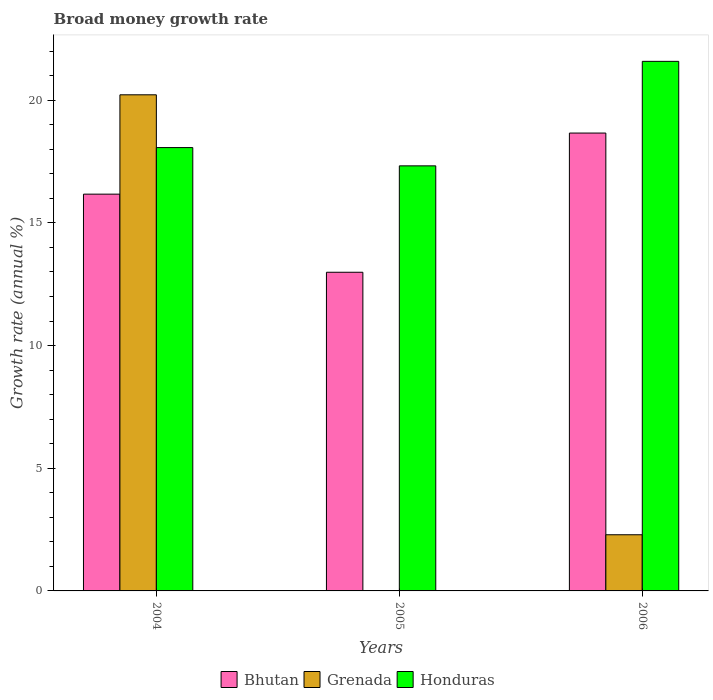How many different coloured bars are there?
Ensure brevity in your answer.  3. Are the number of bars per tick equal to the number of legend labels?
Ensure brevity in your answer.  No. How many bars are there on the 1st tick from the left?
Your answer should be compact. 3. How many bars are there on the 2nd tick from the right?
Make the answer very short. 2. What is the label of the 2nd group of bars from the left?
Offer a terse response. 2005. In how many cases, is the number of bars for a given year not equal to the number of legend labels?
Your answer should be compact. 1. What is the growth rate in Bhutan in 2005?
Provide a succinct answer. 12.99. Across all years, what is the maximum growth rate in Grenada?
Offer a terse response. 20.22. Across all years, what is the minimum growth rate in Bhutan?
Ensure brevity in your answer.  12.99. In which year was the growth rate in Grenada maximum?
Your response must be concise. 2004. What is the total growth rate in Bhutan in the graph?
Provide a short and direct response. 47.83. What is the difference between the growth rate in Bhutan in 2004 and that in 2006?
Provide a succinct answer. -2.49. What is the difference between the growth rate in Bhutan in 2005 and the growth rate in Honduras in 2006?
Provide a short and direct response. -8.6. What is the average growth rate in Honduras per year?
Keep it short and to the point. 18.99. In the year 2006, what is the difference between the growth rate in Grenada and growth rate in Bhutan?
Keep it short and to the point. -16.37. In how many years, is the growth rate in Honduras greater than 1 %?
Offer a terse response. 3. What is the ratio of the growth rate in Bhutan in 2005 to that in 2006?
Keep it short and to the point. 0.7. Is the growth rate in Bhutan in 2005 less than that in 2006?
Offer a very short reply. Yes. What is the difference between the highest and the second highest growth rate in Honduras?
Your answer should be very brief. 3.51. What is the difference between the highest and the lowest growth rate in Grenada?
Offer a very short reply. 20.22. In how many years, is the growth rate in Honduras greater than the average growth rate in Honduras taken over all years?
Keep it short and to the point. 1. How many bars are there?
Your answer should be very brief. 8. What is the difference between two consecutive major ticks on the Y-axis?
Offer a terse response. 5. Does the graph contain any zero values?
Ensure brevity in your answer.  Yes. How many legend labels are there?
Offer a terse response. 3. How are the legend labels stacked?
Your answer should be very brief. Horizontal. What is the title of the graph?
Ensure brevity in your answer.  Broad money growth rate. What is the label or title of the Y-axis?
Your answer should be very brief. Growth rate (annual %). What is the Growth rate (annual %) in Bhutan in 2004?
Provide a short and direct response. 16.17. What is the Growth rate (annual %) in Grenada in 2004?
Offer a terse response. 20.22. What is the Growth rate (annual %) in Honduras in 2004?
Make the answer very short. 18.07. What is the Growth rate (annual %) in Bhutan in 2005?
Provide a short and direct response. 12.99. What is the Growth rate (annual %) of Honduras in 2005?
Your answer should be compact. 17.33. What is the Growth rate (annual %) of Bhutan in 2006?
Ensure brevity in your answer.  18.66. What is the Growth rate (annual %) of Grenada in 2006?
Offer a terse response. 2.29. What is the Growth rate (annual %) of Honduras in 2006?
Your answer should be compact. 21.59. Across all years, what is the maximum Growth rate (annual %) in Bhutan?
Provide a succinct answer. 18.66. Across all years, what is the maximum Growth rate (annual %) in Grenada?
Your answer should be compact. 20.22. Across all years, what is the maximum Growth rate (annual %) of Honduras?
Offer a terse response. 21.59. Across all years, what is the minimum Growth rate (annual %) of Bhutan?
Provide a short and direct response. 12.99. Across all years, what is the minimum Growth rate (annual %) in Grenada?
Offer a terse response. 0. Across all years, what is the minimum Growth rate (annual %) in Honduras?
Make the answer very short. 17.33. What is the total Growth rate (annual %) in Bhutan in the graph?
Your answer should be compact. 47.83. What is the total Growth rate (annual %) of Grenada in the graph?
Provide a short and direct response. 22.51. What is the total Growth rate (annual %) in Honduras in the graph?
Offer a very short reply. 56.98. What is the difference between the Growth rate (annual %) of Bhutan in 2004 and that in 2005?
Your answer should be very brief. 3.18. What is the difference between the Growth rate (annual %) of Honduras in 2004 and that in 2005?
Your answer should be very brief. 0.74. What is the difference between the Growth rate (annual %) of Bhutan in 2004 and that in 2006?
Give a very brief answer. -2.49. What is the difference between the Growth rate (annual %) of Grenada in 2004 and that in 2006?
Provide a succinct answer. 17.93. What is the difference between the Growth rate (annual %) in Honduras in 2004 and that in 2006?
Give a very brief answer. -3.51. What is the difference between the Growth rate (annual %) of Bhutan in 2005 and that in 2006?
Provide a succinct answer. -5.67. What is the difference between the Growth rate (annual %) of Honduras in 2005 and that in 2006?
Your answer should be compact. -4.26. What is the difference between the Growth rate (annual %) of Bhutan in 2004 and the Growth rate (annual %) of Honduras in 2005?
Your answer should be very brief. -1.15. What is the difference between the Growth rate (annual %) in Grenada in 2004 and the Growth rate (annual %) in Honduras in 2005?
Your answer should be very brief. 2.9. What is the difference between the Growth rate (annual %) of Bhutan in 2004 and the Growth rate (annual %) of Grenada in 2006?
Your answer should be very brief. 13.88. What is the difference between the Growth rate (annual %) of Bhutan in 2004 and the Growth rate (annual %) of Honduras in 2006?
Provide a succinct answer. -5.41. What is the difference between the Growth rate (annual %) in Grenada in 2004 and the Growth rate (annual %) in Honduras in 2006?
Keep it short and to the point. -1.36. What is the difference between the Growth rate (annual %) of Bhutan in 2005 and the Growth rate (annual %) of Grenada in 2006?
Your response must be concise. 10.7. What is the difference between the Growth rate (annual %) of Bhutan in 2005 and the Growth rate (annual %) of Honduras in 2006?
Offer a terse response. -8.6. What is the average Growth rate (annual %) of Bhutan per year?
Provide a succinct answer. 15.94. What is the average Growth rate (annual %) in Grenada per year?
Offer a very short reply. 7.5. What is the average Growth rate (annual %) in Honduras per year?
Give a very brief answer. 18.99. In the year 2004, what is the difference between the Growth rate (annual %) of Bhutan and Growth rate (annual %) of Grenada?
Ensure brevity in your answer.  -4.05. In the year 2004, what is the difference between the Growth rate (annual %) in Bhutan and Growth rate (annual %) in Honduras?
Give a very brief answer. -1.9. In the year 2004, what is the difference between the Growth rate (annual %) of Grenada and Growth rate (annual %) of Honduras?
Ensure brevity in your answer.  2.15. In the year 2005, what is the difference between the Growth rate (annual %) in Bhutan and Growth rate (annual %) in Honduras?
Offer a very short reply. -4.34. In the year 2006, what is the difference between the Growth rate (annual %) of Bhutan and Growth rate (annual %) of Grenada?
Offer a very short reply. 16.37. In the year 2006, what is the difference between the Growth rate (annual %) in Bhutan and Growth rate (annual %) in Honduras?
Provide a short and direct response. -2.92. In the year 2006, what is the difference between the Growth rate (annual %) of Grenada and Growth rate (annual %) of Honduras?
Make the answer very short. -19.3. What is the ratio of the Growth rate (annual %) in Bhutan in 2004 to that in 2005?
Your answer should be compact. 1.25. What is the ratio of the Growth rate (annual %) in Honduras in 2004 to that in 2005?
Provide a succinct answer. 1.04. What is the ratio of the Growth rate (annual %) in Bhutan in 2004 to that in 2006?
Your answer should be very brief. 0.87. What is the ratio of the Growth rate (annual %) of Grenada in 2004 to that in 2006?
Keep it short and to the point. 8.83. What is the ratio of the Growth rate (annual %) of Honduras in 2004 to that in 2006?
Provide a short and direct response. 0.84. What is the ratio of the Growth rate (annual %) in Bhutan in 2005 to that in 2006?
Ensure brevity in your answer.  0.7. What is the ratio of the Growth rate (annual %) in Honduras in 2005 to that in 2006?
Provide a succinct answer. 0.8. What is the difference between the highest and the second highest Growth rate (annual %) of Bhutan?
Keep it short and to the point. 2.49. What is the difference between the highest and the second highest Growth rate (annual %) of Honduras?
Your answer should be compact. 3.51. What is the difference between the highest and the lowest Growth rate (annual %) in Bhutan?
Your response must be concise. 5.67. What is the difference between the highest and the lowest Growth rate (annual %) of Grenada?
Your answer should be compact. 20.22. What is the difference between the highest and the lowest Growth rate (annual %) in Honduras?
Provide a short and direct response. 4.26. 